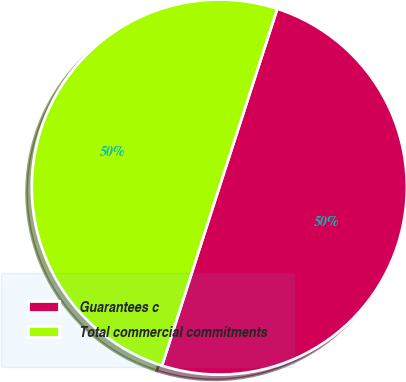Convert chart. <chart><loc_0><loc_0><loc_500><loc_500><pie_chart><fcel>Guarantees c<fcel>Total commercial commitments<nl><fcel>49.95%<fcel>50.05%<nl></chart> 